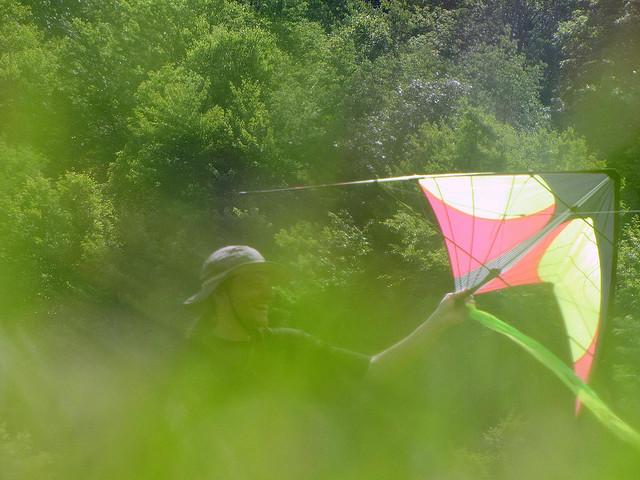What is stuck in the tree?
Be succinct. Kite. What is the dominant color of this picture?
Keep it brief. Green. Was a filter used to take this photo?
Keep it brief. Yes. 